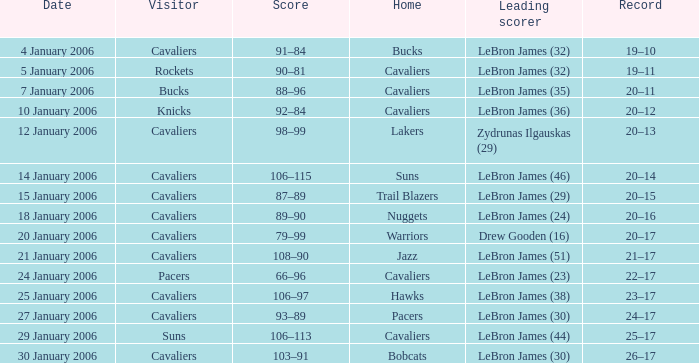Who was the leading score in the game at the Warriors? Drew Gooden (16). 